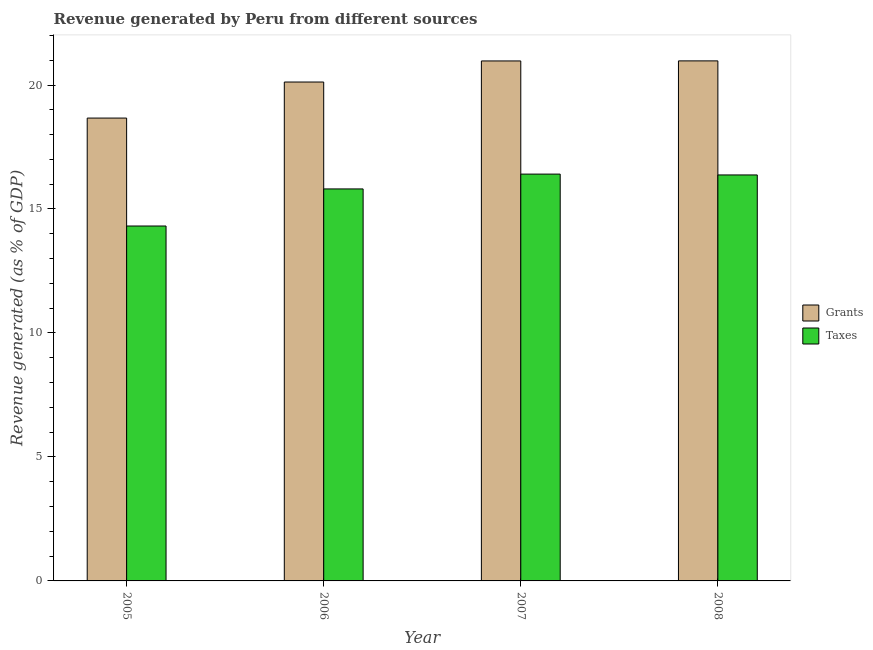How many different coloured bars are there?
Ensure brevity in your answer.  2. Are the number of bars on each tick of the X-axis equal?
Give a very brief answer. Yes. How many bars are there on the 2nd tick from the left?
Provide a short and direct response. 2. What is the revenue generated by grants in 2007?
Ensure brevity in your answer.  20.97. Across all years, what is the maximum revenue generated by grants?
Provide a succinct answer. 20.97. Across all years, what is the minimum revenue generated by grants?
Keep it short and to the point. 18.67. What is the total revenue generated by grants in the graph?
Ensure brevity in your answer.  80.73. What is the difference between the revenue generated by grants in 2005 and that in 2008?
Offer a very short reply. -2.31. What is the difference between the revenue generated by grants in 2005 and the revenue generated by taxes in 2006?
Your answer should be very brief. -1.45. What is the average revenue generated by taxes per year?
Your answer should be very brief. 15.73. In the year 2007, what is the difference between the revenue generated by grants and revenue generated by taxes?
Keep it short and to the point. 0. What is the ratio of the revenue generated by taxes in 2006 to that in 2008?
Your answer should be compact. 0.97. What is the difference between the highest and the second highest revenue generated by grants?
Offer a terse response. 0. What is the difference between the highest and the lowest revenue generated by grants?
Make the answer very short. 2.31. In how many years, is the revenue generated by taxes greater than the average revenue generated by taxes taken over all years?
Offer a very short reply. 3. Is the sum of the revenue generated by taxes in 2005 and 2008 greater than the maximum revenue generated by grants across all years?
Give a very brief answer. Yes. What does the 1st bar from the left in 2005 represents?
Offer a very short reply. Grants. What does the 2nd bar from the right in 2006 represents?
Your answer should be compact. Grants. Does the graph contain grids?
Provide a short and direct response. No. Where does the legend appear in the graph?
Your answer should be very brief. Center right. What is the title of the graph?
Offer a very short reply. Revenue generated by Peru from different sources. What is the label or title of the X-axis?
Provide a succinct answer. Year. What is the label or title of the Y-axis?
Give a very brief answer. Revenue generated (as % of GDP). What is the Revenue generated (as % of GDP) of Grants in 2005?
Ensure brevity in your answer.  18.67. What is the Revenue generated (as % of GDP) in Taxes in 2005?
Ensure brevity in your answer.  14.31. What is the Revenue generated (as % of GDP) of Grants in 2006?
Provide a succinct answer. 20.12. What is the Revenue generated (as % of GDP) in Taxes in 2006?
Your answer should be compact. 15.81. What is the Revenue generated (as % of GDP) in Grants in 2007?
Offer a very short reply. 20.97. What is the Revenue generated (as % of GDP) in Taxes in 2007?
Provide a succinct answer. 16.41. What is the Revenue generated (as % of GDP) in Grants in 2008?
Provide a succinct answer. 20.97. What is the Revenue generated (as % of GDP) of Taxes in 2008?
Your response must be concise. 16.37. Across all years, what is the maximum Revenue generated (as % of GDP) of Grants?
Provide a short and direct response. 20.97. Across all years, what is the maximum Revenue generated (as % of GDP) in Taxes?
Offer a very short reply. 16.41. Across all years, what is the minimum Revenue generated (as % of GDP) in Grants?
Provide a succinct answer. 18.67. Across all years, what is the minimum Revenue generated (as % of GDP) in Taxes?
Your answer should be compact. 14.31. What is the total Revenue generated (as % of GDP) of Grants in the graph?
Make the answer very short. 80.73. What is the total Revenue generated (as % of GDP) of Taxes in the graph?
Offer a terse response. 62.9. What is the difference between the Revenue generated (as % of GDP) in Grants in 2005 and that in 2006?
Your response must be concise. -1.45. What is the difference between the Revenue generated (as % of GDP) in Taxes in 2005 and that in 2006?
Ensure brevity in your answer.  -1.5. What is the difference between the Revenue generated (as % of GDP) of Grants in 2005 and that in 2007?
Your answer should be very brief. -2.3. What is the difference between the Revenue generated (as % of GDP) in Taxes in 2005 and that in 2007?
Keep it short and to the point. -2.09. What is the difference between the Revenue generated (as % of GDP) in Grants in 2005 and that in 2008?
Keep it short and to the point. -2.31. What is the difference between the Revenue generated (as % of GDP) in Taxes in 2005 and that in 2008?
Make the answer very short. -2.06. What is the difference between the Revenue generated (as % of GDP) in Grants in 2006 and that in 2007?
Offer a terse response. -0.85. What is the difference between the Revenue generated (as % of GDP) in Taxes in 2006 and that in 2007?
Offer a very short reply. -0.6. What is the difference between the Revenue generated (as % of GDP) in Grants in 2006 and that in 2008?
Give a very brief answer. -0.85. What is the difference between the Revenue generated (as % of GDP) in Taxes in 2006 and that in 2008?
Provide a short and direct response. -0.56. What is the difference between the Revenue generated (as % of GDP) of Grants in 2007 and that in 2008?
Offer a terse response. -0. What is the difference between the Revenue generated (as % of GDP) of Taxes in 2007 and that in 2008?
Provide a succinct answer. 0.03. What is the difference between the Revenue generated (as % of GDP) in Grants in 2005 and the Revenue generated (as % of GDP) in Taxes in 2006?
Ensure brevity in your answer.  2.86. What is the difference between the Revenue generated (as % of GDP) of Grants in 2005 and the Revenue generated (as % of GDP) of Taxes in 2007?
Your answer should be very brief. 2.26. What is the difference between the Revenue generated (as % of GDP) of Grants in 2005 and the Revenue generated (as % of GDP) of Taxes in 2008?
Provide a short and direct response. 2.29. What is the difference between the Revenue generated (as % of GDP) in Grants in 2006 and the Revenue generated (as % of GDP) in Taxes in 2007?
Ensure brevity in your answer.  3.71. What is the difference between the Revenue generated (as % of GDP) in Grants in 2006 and the Revenue generated (as % of GDP) in Taxes in 2008?
Provide a short and direct response. 3.75. What is the difference between the Revenue generated (as % of GDP) of Grants in 2007 and the Revenue generated (as % of GDP) of Taxes in 2008?
Keep it short and to the point. 4.6. What is the average Revenue generated (as % of GDP) of Grants per year?
Offer a terse response. 20.18. What is the average Revenue generated (as % of GDP) in Taxes per year?
Keep it short and to the point. 15.73. In the year 2005, what is the difference between the Revenue generated (as % of GDP) of Grants and Revenue generated (as % of GDP) of Taxes?
Give a very brief answer. 4.35. In the year 2006, what is the difference between the Revenue generated (as % of GDP) of Grants and Revenue generated (as % of GDP) of Taxes?
Your answer should be very brief. 4.31. In the year 2007, what is the difference between the Revenue generated (as % of GDP) in Grants and Revenue generated (as % of GDP) in Taxes?
Provide a succinct answer. 4.56. In the year 2008, what is the difference between the Revenue generated (as % of GDP) in Grants and Revenue generated (as % of GDP) in Taxes?
Give a very brief answer. 4.6. What is the ratio of the Revenue generated (as % of GDP) of Grants in 2005 to that in 2006?
Provide a short and direct response. 0.93. What is the ratio of the Revenue generated (as % of GDP) in Taxes in 2005 to that in 2006?
Your answer should be compact. 0.91. What is the ratio of the Revenue generated (as % of GDP) in Grants in 2005 to that in 2007?
Make the answer very short. 0.89. What is the ratio of the Revenue generated (as % of GDP) in Taxes in 2005 to that in 2007?
Provide a succinct answer. 0.87. What is the ratio of the Revenue generated (as % of GDP) in Grants in 2005 to that in 2008?
Your response must be concise. 0.89. What is the ratio of the Revenue generated (as % of GDP) in Taxes in 2005 to that in 2008?
Offer a terse response. 0.87. What is the ratio of the Revenue generated (as % of GDP) in Grants in 2006 to that in 2007?
Make the answer very short. 0.96. What is the ratio of the Revenue generated (as % of GDP) of Taxes in 2006 to that in 2007?
Your response must be concise. 0.96. What is the ratio of the Revenue generated (as % of GDP) in Grants in 2006 to that in 2008?
Make the answer very short. 0.96. What is the ratio of the Revenue generated (as % of GDP) in Taxes in 2006 to that in 2008?
Provide a succinct answer. 0.97. What is the ratio of the Revenue generated (as % of GDP) of Taxes in 2007 to that in 2008?
Ensure brevity in your answer.  1. What is the difference between the highest and the second highest Revenue generated (as % of GDP) of Grants?
Provide a succinct answer. 0. What is the difference between the highest and the second highest Revenue generated (as % of GDP) in Taxes?
Ensure brevity in your answer.  0.03. What is the difference between the highest and the lowest Revenue generated (as % of GDP) of Grants?
Give a very brief answer. 2.31. What is the difference between the highest and the lowest Revenue generated (as % of GDP) in Taxes?
Offer a very short reply. 2.09. 